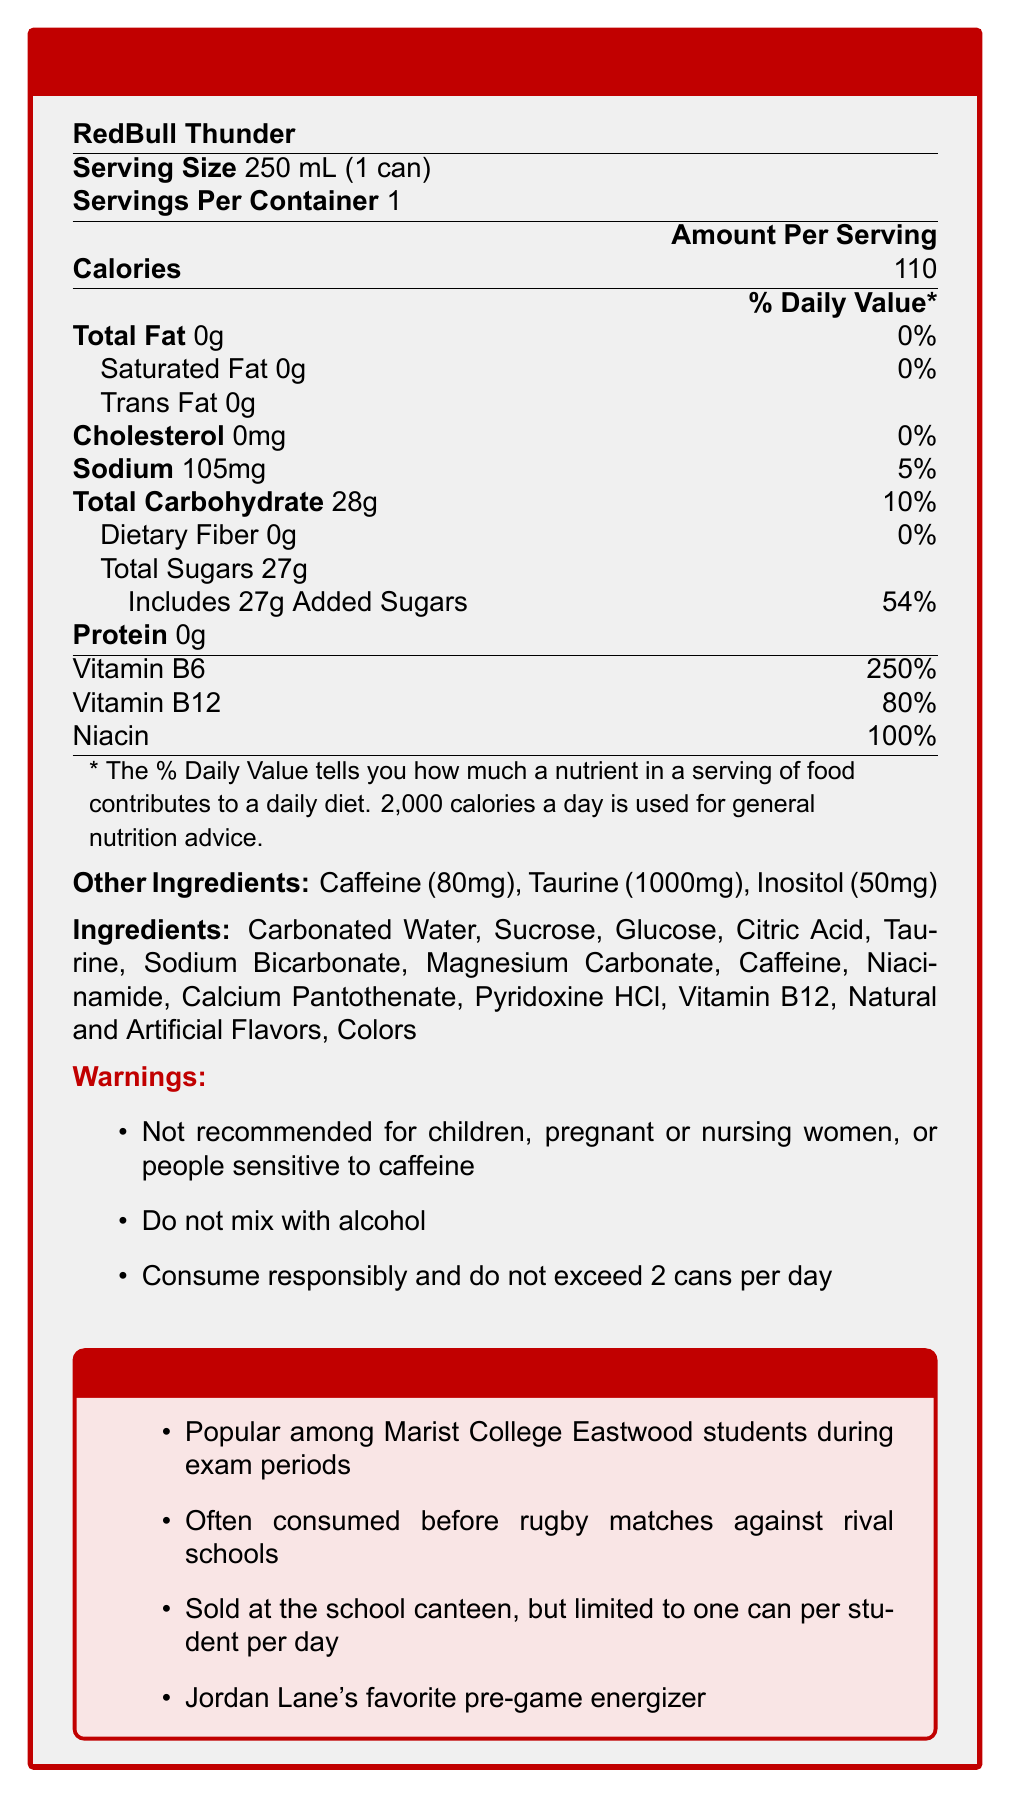What is the serving size of RedBull Thunder? The serving size is explicitly mentioned as "250 mL (1 can)" in the document.
Answer: 250 mL (1 can) How many calories are in one serving of RedBull Thunder? The document specifies that one serving contains 110 calories.
Answer: 110 calories What percentage of the Daily Value for Vitamin B6 does RedBull Thunder provide? The document states that the vitamin B6 content is 250% of the Daily Value.
Answer: 250% What is the sodium content in one serving of RedBull Thunder? The sodium content per serving is listed as 105mg.
Answer: 105mg What are the first three ingredients listed for RedBull Thunder? The first three ingredients listed in the document are Carbonated Water, Sucrose, and Glucose.
Answer: Carbonated Water, Sucrose, Glucose Is RedBull Thunder recommended for children? The document explicitly states that it is not recommended for children.
Answer: No Which vitamin in RedBull Thunder has the highest percentage of the Daily Value? 
A. Vitamin B6 
B. Vitamin B12 
C. Niacin 
D. Vitamin C The document shows that Vitamin B6 has the highest percentage of the Daily Value at 250%.
Answer: A What is the warning related to alcohol consumption mentioned in the document? 
A. Do not mix with alcohol 
B. Only mix with one type of alcohol 
C. Mix with water before drinking 
D. Only drink with food The warning section specifically states, "Do not mix with alcohol."
Answer: A Does RedBull Thunder contain dietary fiber? According to the document, the dietary fiber content is 0g.
Answer: No Can we determine the exact amount of Vitamin C in RedBull Thunder from the document? The document does not mention Vitamin C, thus its amount cannot be determined.
Answer: Cannot be determined What are some popular times or events at Marist College Eastwood for consuming RedBull Thunder? According to the document, students commonly consume RedBull Thunder during exam periods and before rugby matches against rival schools.
Answer: Exam periods and before rugby matches against rival schools Summarize the main components of the document. The summary captures the essential parts of the document, including nutritional information, popularity among students, key ingredients, and warnings.
Answer: The document is a Nutrition Facts Label for RedBull Thunder, detailing its nutritional content, ingredients, and warnings. It highlights that the energy drink is popular among Marist College Eastwood students, especially during exam periods and before rugby matches. Key nutrients include high percentages of Vitamin B6, B12, and Niacin, and it contains 110 calories per serving along with 27g of sugars. Caffeine and taurine are notable ingredients, and there are specific warnings regarding consumption. Jordan Lane’s pre-game preference is also mentioned. 